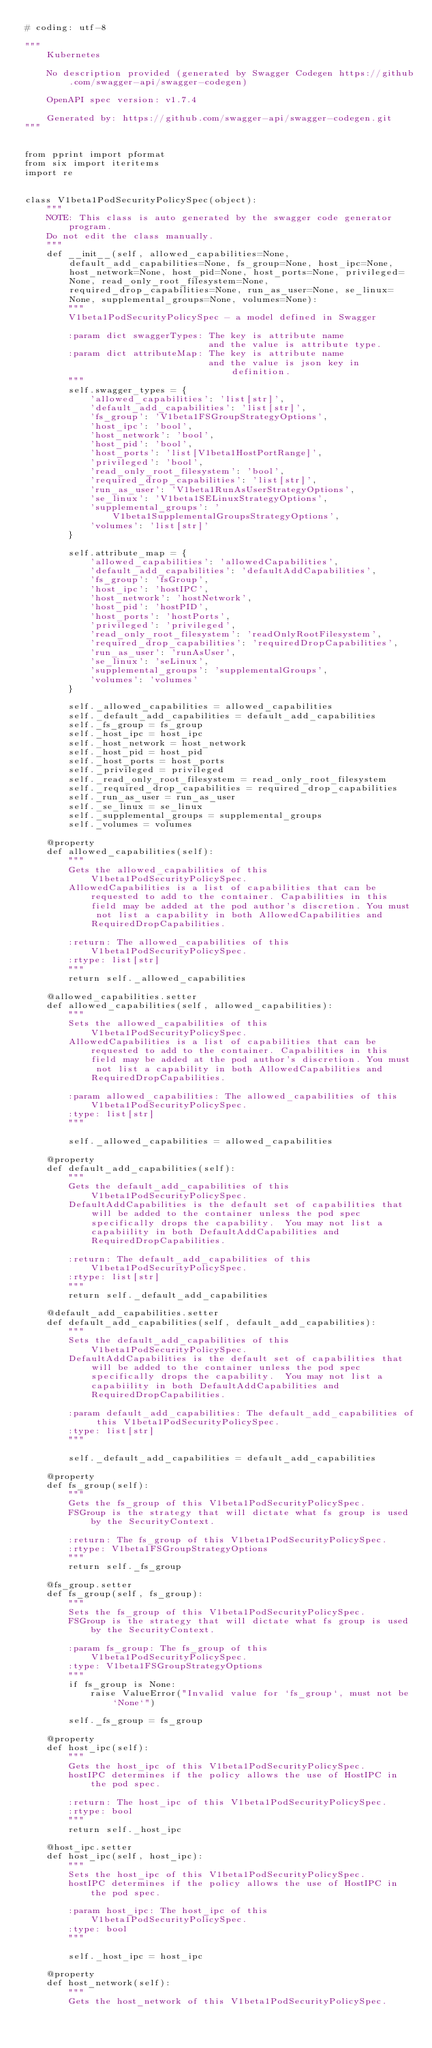<code> <loc_0><loc_0><loc_500><loc_500><_Python_># coding: utf-8

"""
    Kubernetes

    No description provided (generated by Swagger Codegen https://github.com/swagger-api/swagger-codegen)

    OpenAPI spec version: v1.7.4
    
    Generated by: https://github.com/swagger-api/swagger-codegen.git
"""


from pprint import pformat
from six import iteritems
import re


class V1beta1PodSecurityPolicySpec(object):
    """
    NOTE: This class is auto generated by the swagger code generator program.
    Do not edit the class manually.
    """
    def __init__(self, allowed_capabilities=None, default_add_capabilities=None, fs_group=None, host_ipc=None, host_network=None, host_pid=None, host_ports=None, privileged=None, read_only_root_filesystem=None, required_drop_capabilities=None, run_as_user=None, se_linux=None, supplemental_groups=None, volumes=None):
        """
        V1beta1PodSecurityPolicySpec - a model defined in Swagger

        :param dict swaggerTypes: The key is attribute name
                                  and the value is attribute type.
        :param dict attributeMap: The key is attribute name
                                  and the value is json key in definition.
        """
        self.swagger_types = {
            'allowed_capabilities': 'list[str]',
            'default_add_capabilities': 'list[str]',
            'fs_group': 'V1beta1FSGroupStrategyOptions',
            'host_ipc': 'bool',
            'host_network': 'bool',
            'host_pid': 'bool',
            'host_ports': 'list[V1beta1HostPortRange]',
            'privileged': 'bool',
            'read_only_root_filesystem': 'bool',
            'required_drop_capabilities': 'list[str]',
            'run_as_user': 'V1beta1RunAsUserStrategyOptions',
            'se_linux': 'V1beta1SELinuxStrategyOptions',
            'supplemental_groups': 'V1beta1SupplementalGroupsStrategyOptions',
            'volumes': 'list[str]'
        }

        self.attribute_map = {
            'allowed_capabilities': 'allowedCapabilities',
            'default_add_capabilities': 'defaultAddCapabilities',
            'fs_group': 'fsGroup',
            'host_ipc': 'hostIPC',
            'host_network': 'hostNetwork',
            'host_pid': 'hostPID',
            'host_ports': 'hostPorts',
            'privileged': 'privileged',
            'read_only_root_filesystem': 'readOnlyRootFilesystem',
            'required_drop_capabilities': 'requiredDropCapabilities',
            'run_as_user': 'runAsUser',
            'se_linux': 'seLinux',
            'supplemental_groups': 'supplementalGroups',
            'volumes': 'volumes'
        }

        self._allowed_capabilities = allowed_capabilities
        self._default_add_capabilities = default_add_capabilities
        self._fs_group = fs_group
        self._host_ipc = host_ipc
        self._host_network = host_network
        self._host_pid = host_pid
        self._host_ports = host_ports
        self._privileged = privileged
        self._read_only_root_filesystem = read_only_root_filesystem
        self._required_drop_capabilities = required_drop_capabilities
        self._run_as_user = run_as_user
        self._se_linux = se_linux
        self._supplemental_groups = supplemental_groups
        self._volumes = volumes

    @property
    def allowed_capabilities(self):
        """
        Gets the allowed_capabilities of this V1beta1PodSecurityPolicySpec.
        AllowedCapabilities is a list of capabilities that can be requested to add to the container. Capabilities in this field may be added at the pod author's discretion. You must not list a capability in both AllowedCapabilities and RequiredDropCapabilities.

        :return: The allowed_capabilities of this V1beta1PodSecurityPolicySpec.
        :rtype: list[str]
        """
        return self._allowed_capabilities

    @allowed_capabilities.setter
    def allowed_capabilities(self, allowed_capabilities):
        """
        Sets the allowed_capabilities of this V1beta1PodSecurityPolicySpec.
        AllowedCapabilities is a list of capabilities that can be requested to add to the container. Capabilities in this field may be added at the pod author's discretion. You must not list a capability in both AllowedCapabilities and RequiredDropCapabilities.

        :param allowed_capabilities: The allowed_capabilities of this V1beta1PodSecurityPolicySpec.
        :type: list[str]
        """

        self._allowed_capabilities = allowed_capabilities

    @property
    def default_add_capabilities(self):
        """
        Gets the default_add_capabilities of this V1beta1PodSecurityPolicySpec.
        DefaultAddCapabilities is the default set of capabilities that will be added to the container unless the pod spec specifically drops the capability.  You may not list a capabiility in both DefaultAddCapabilities and RequiredDropCapabilities.

        :return: The default_add_capabilities of this V1beta1PodSecurityPolicySpec.
        :rtype: list[str]
        """
        return self._default_add_capabilities

    @default_add_capabilities.setter
    def default_add_capabilities(self, default_add_capabilities):
        """
        Sets the default_add_capabilities of this V1beta1PodSecurityPolicySpec.
        DefaultAddCapabilities is the default set of capabilities that will be added to the container unless the pod spec specifically drops the capability.  You may not list a capabiility in both DefaultAddCapabilities and RequiredDropCapabilities.

        :param default_add_capabilities: The default_add_capabilities of this V1beta1PodSecurityPolicySpec.
        :type: list[str]
        """

        self._default_add_capabilities = default_add_capabilities

    @property
    def fs_group(self):
        """
        Gets the fs_group of this V1beta1PodSecurityPolicySpec.
        FSGroup is the strategy that will dictate what fs group is used by the SecurityContext.

        :return: The fs_group of this V1beta1PodSecurityPolicySpec.
        :rtype: V1beta1FSGroupStrategyOptions
        """
        return self._fs_group

    @fs_group.setter
    def fs_group(self, fs_group):
        """
        Sets the fs_group of this V1beta1PodSecurityPolicySpec.
        FSGroup is the strategy that will dictate what fs group is used by the SecurityContext.

        :param fs_group: The fs_group of this V1beta1PodSecurityPolicySpec.
        :type: V1beta1FSGroupStrategyOptions
        """
        if fs_group is None:
            raise ValueError("Invalid value for `fs_group`, must not be `None`")

        self._fs_group = fs_group

    @property
    def host_ipc(self):
        """
        Gets the host_ipc of this V1beta1PodSecurityPolicySpec.
        hostIPC determines if the policy allows the use of HostIPC in the pod spec.

        :return: The host_ipc of this V1beta1PodSecurityPolicySpec.
        :rtype: bool
        """
        return self._host_ipc

    @host_ipc.setter
    def host_ipc(self, host_ipc):
        """
        Sets the host_ipc of this V1beta1PodSecurityPolicySpec.
        hostIPC determines if the policy allows the use of HostIPC in the pod spec.

        :param host_ipc: The host_ipc of this V1beta1PodSecurityPolicySpec.
        :type: bool
        """

        self._host_ipc = host_ipc

    @property
    def host_network(self):
        """
        Gets the host_network of this V1beta1PodSecurityPolicySpec.</code> 